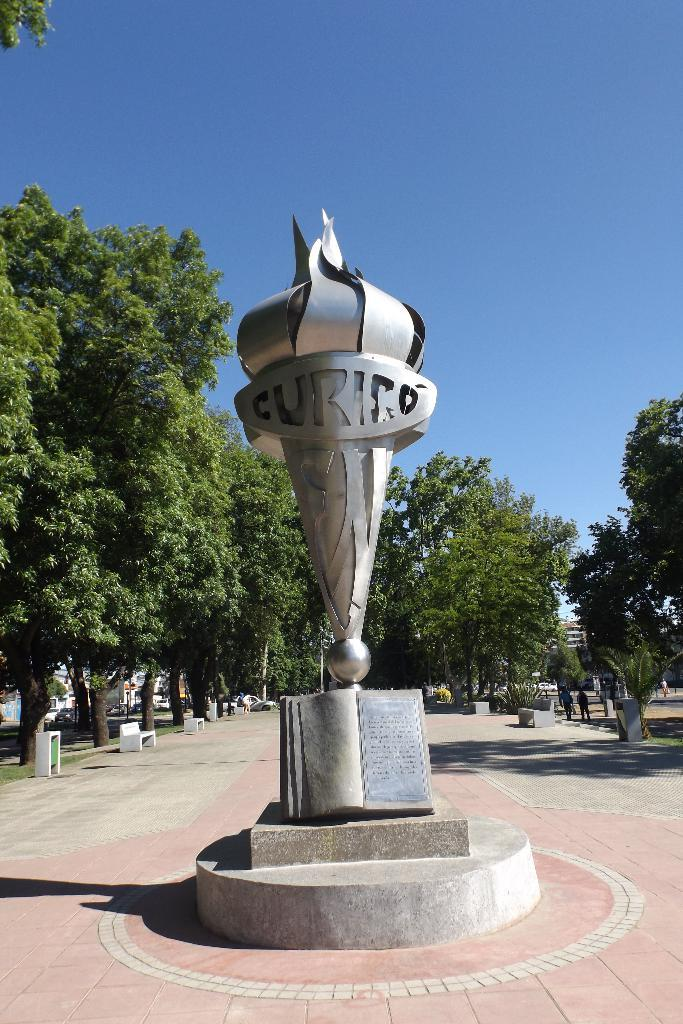<image>
Provide a brief description of the given image. A statue that has the letter CURICO on it. 